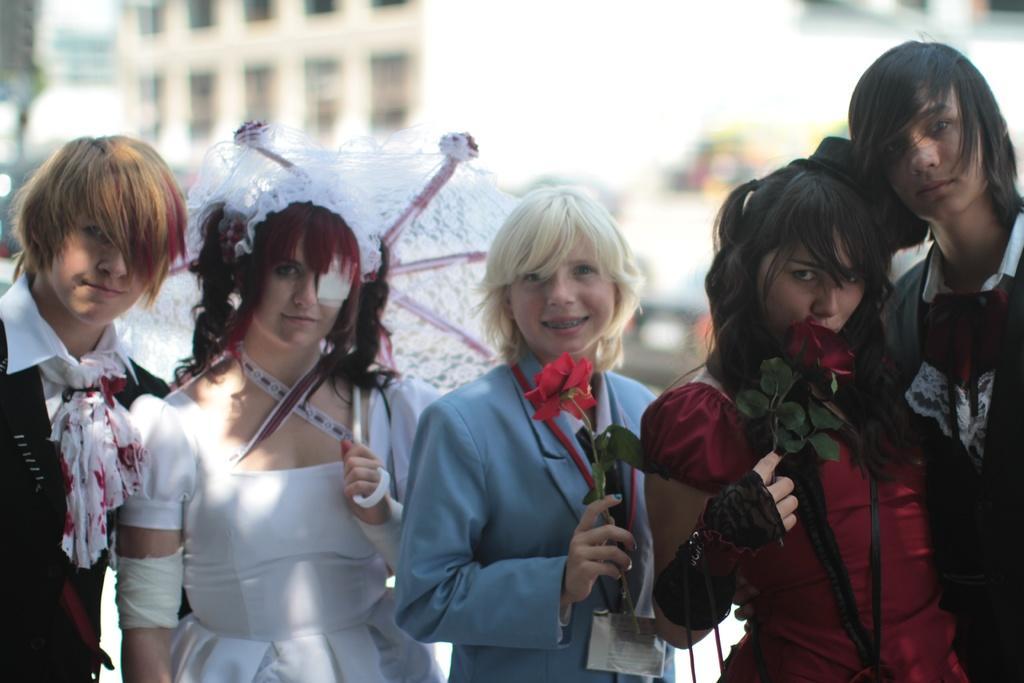How would you summarize this image in a sentence or two? In this image I can see few people standing. They are wearing different color dress. They are holding a umbrella and roses Back I can see building. 